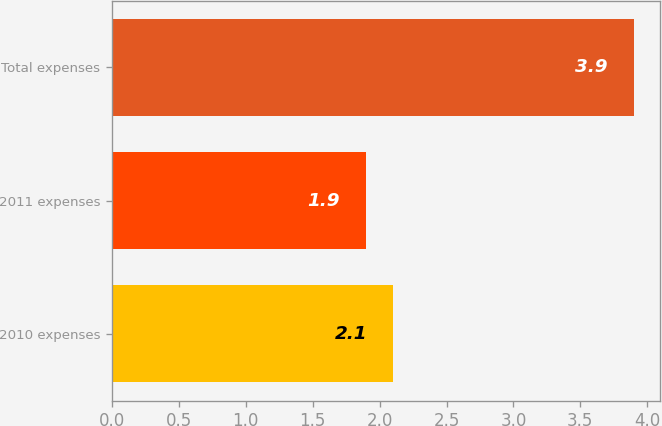Convert chart to OTSL. <chart><loc_0><loc_0><loc_500><loc_500><bar_chart><fcel>2010 expenses<fcel>2011 expenses<fcel>Total expenses<nl><fcel>2.1<fcel>1.9<fcel>3.9<nl></chart> 